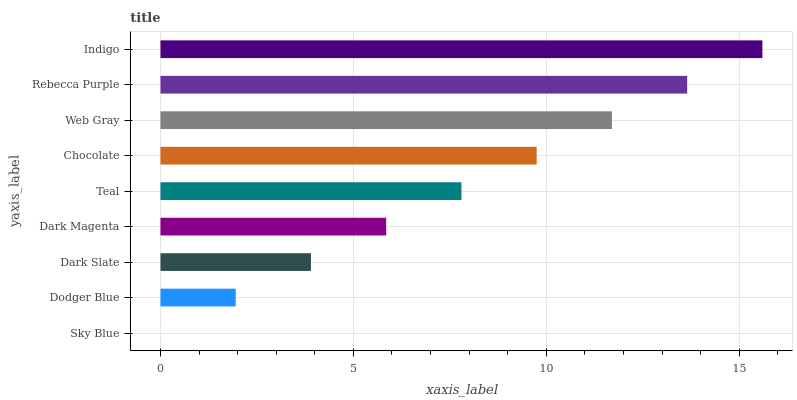Is Sky Blue the minimum?
Answer yes or no. Yes. Is Indigo the maximum?
Answer yes or no. Yes. Is Dodger Blue the minimum?
Answer yes or no. No. Is Dodger Blue the maximum?
Answer yes or no. No. Is Dodger Blue greater than Sky Blue?
Answer yes or no. Yes. Is Sky Blue less than Dodger Blue?
Answer yes or no. Yes. Is Sky Blue greater than Dodger Blue?
Answer yes or no. No. Is Dodger Blue less than Sky Blue?
Answer yes or no. No. Is Teal the high median?
Answer yes or no. Yes. Is Teal the low median?
Answer yes or no. Yes. Is Dark Slate the high median?
Answer yes or no. No. Is Rebecca Purple the low median?
Answer yes or no. No. 